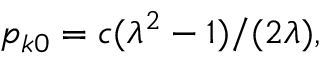<formula> <loc_0><loc_0><loc_500><loc_500>\begin{array} { r } { p _ { k 0 } = c ( \lambda ^ { 2 } - 1 ) / ( 2 \lambda ) , } \end{array}</formula> 